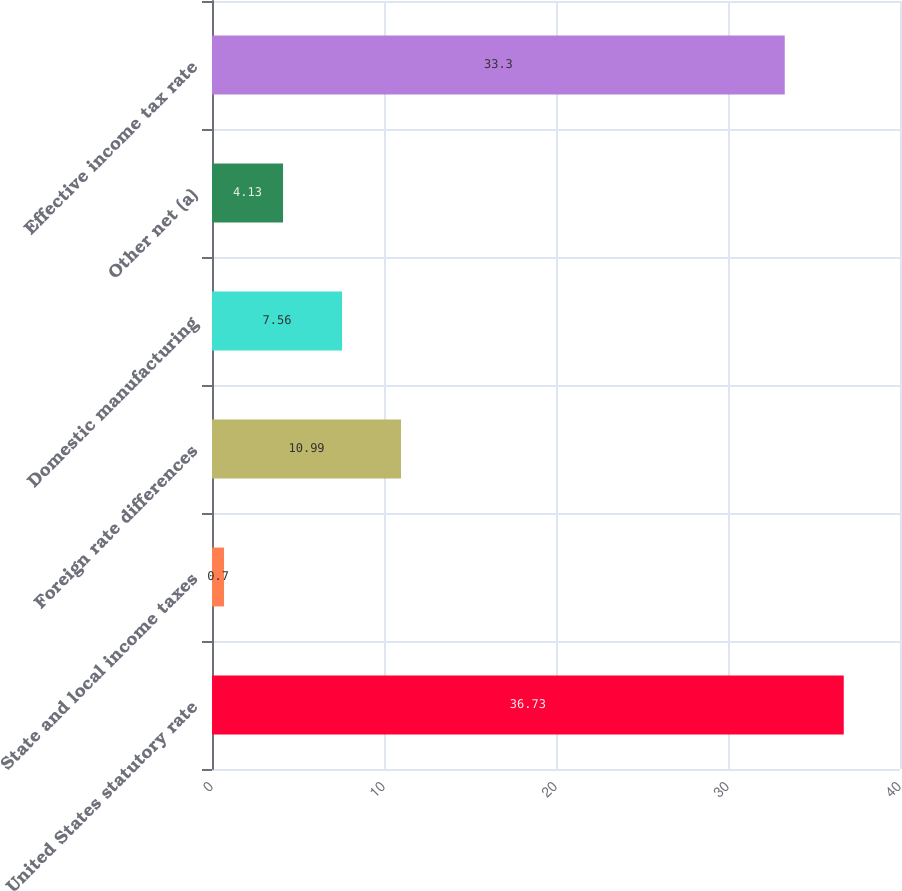Convert chart. <chart><loc_0><loc_0><loc_500><loc_500><bar_chart><fcel>United States statutory rate<fcel>State and local income taxes<fcel>Foreign rate differences<fcel>Domestic manufacturing<fcel>Other net (a)<fcel>Effective income tax rate<nl><fcel>36.73<fcel>0.7<fcel>10.99<fcel>7.56<fcel>4.13<fcel>33.3<nl></chart> 